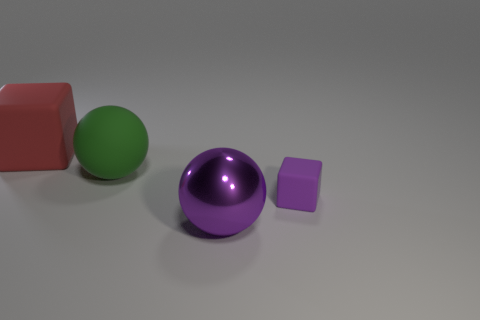Add 2 balls. How many objects exist? 6 Subtract 1 cubes. How many cubes are left? 1 Subtract all purple balls. How many balls are left? 1 Subtract all cyan metal cubes. Subtract all large shiny balls. How many objects are left? 3 Add 4 large green rubber spheres. How many large green rubber spheres are left? 5 Add 4 large red metallic blocks. How many large red metallic blocks exist? 4 Subtract 1 purple spheres. How many objects are left? 3 Subtract all gray cubes. Subtract all blue spheres. How many cubes are left? 2 